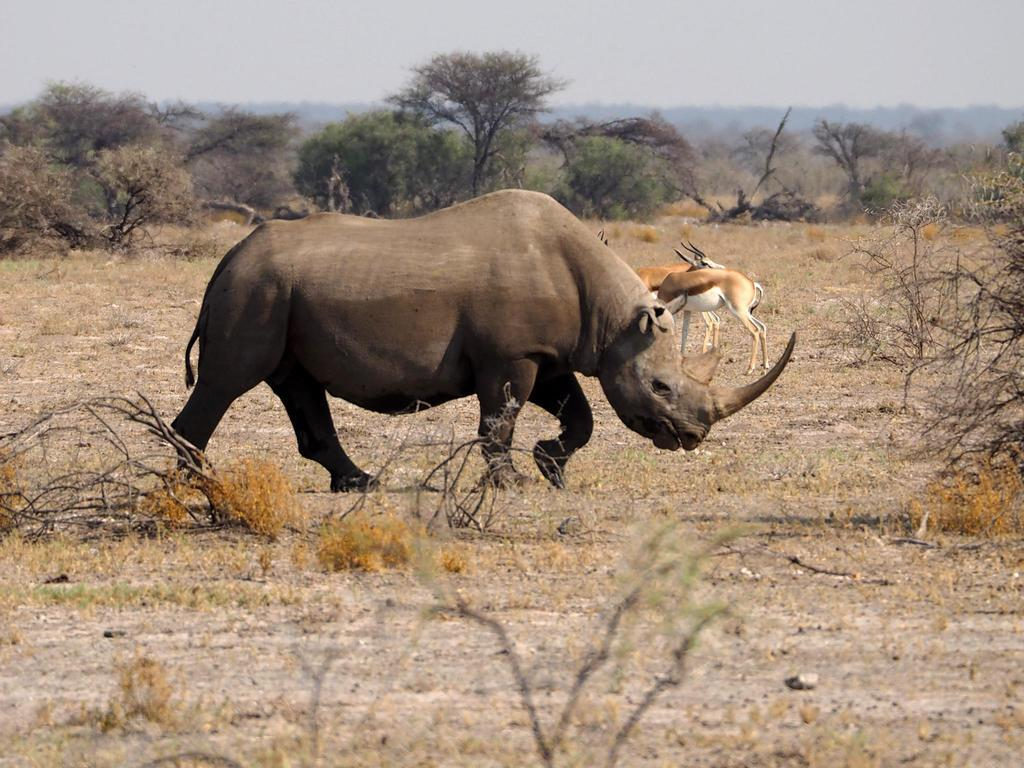What types of living organisms can be seen in the image? There are animals in the image. What can be seen in the background of the image? There is a group of trees in the background of the image. What is present in the foreground of the image? Twigs are present in the foreground of the image. What is visible at the top of the image? The sky is visible at the top of the image. What type of plantation can be seen in the image? There is no plantation present in the image. How many hands are visible in the image? There are no hands visible in the image. 